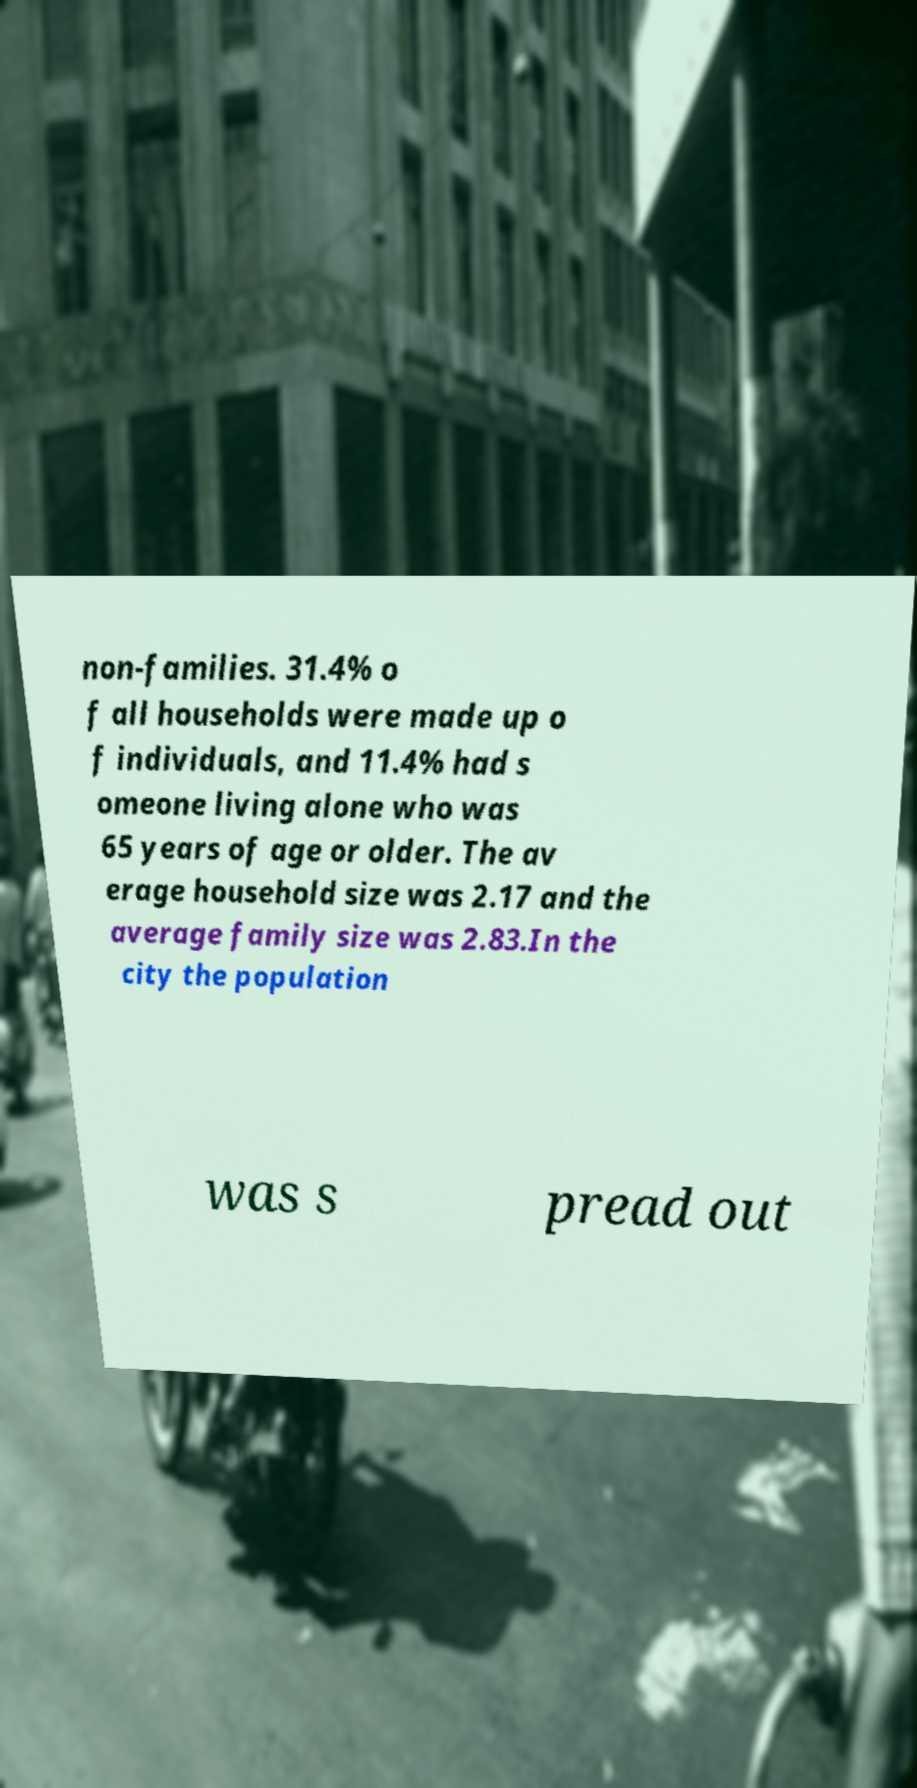What messages or text are displayed in this image? I need them in a readable, typed format. non-families. 31.4% o f all households were made up o f individuals, and 11.4% had s omeone living alone who was 65 years of age or older. The av erage household size was 2.17 and the average family size was 2.83.In the city the population was s pread out 